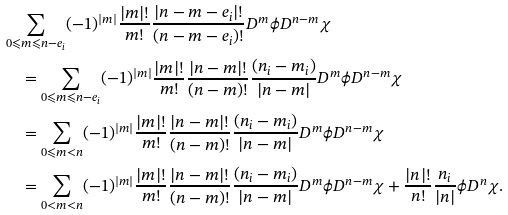<formula> <loc_0><loc_0><loc_500><loc_500>& \sum _ { 0 \leqslant m \leqslant n - e _ { i } } ( - 1 ) ^ { | m | } \frac { | m | ! } { m ! } \frac { | n - m - e _ { i } | ! } { ( n - m - e _ { i } ) ! } D ^ { m } \phi D ^ { n - m } \chi \\ & \quad = \sum _ { 0 \leqslant m \leqslant n - e _ { i } } ( - 1 ) ^ { | m | } \frac { | m | ! } { m ! } \frac { | n - m | ! } { ( n - m ) ! } \frac { ( n _ { i } - m _ { i } ) } { | n - m | } D ^ { m } \phi D ^ { n - m } \chi \\ & \quad = \sum _ { 0 \leqslant m < n } ( - 1 ) ^ { | m | } \frac { | m | ! } { m ! } \frac { | n - m | ! } { ( n - m ) ! } \frac { ( n _ { i } - m _ { i } ) } { | n - m | } D ^ { m } \phi D ^ { n - m } \chi \\ & \quad = \sum _ { 0 < m < n } ( - 1 ) ^ { | m | } \frac { | m | ! } { m ! } \frac { | n - m | ! } { ( n - m ) ! } \frac { ( n _ { i } - m _ { i } ) } { | n - m | } D ^ { m } \phi D ^ { n - m } \chi + \frac { | n | ! } { n ! } \frac { n _ { i } } { | n | } \phi D ^ { n } \chi .</formula> 